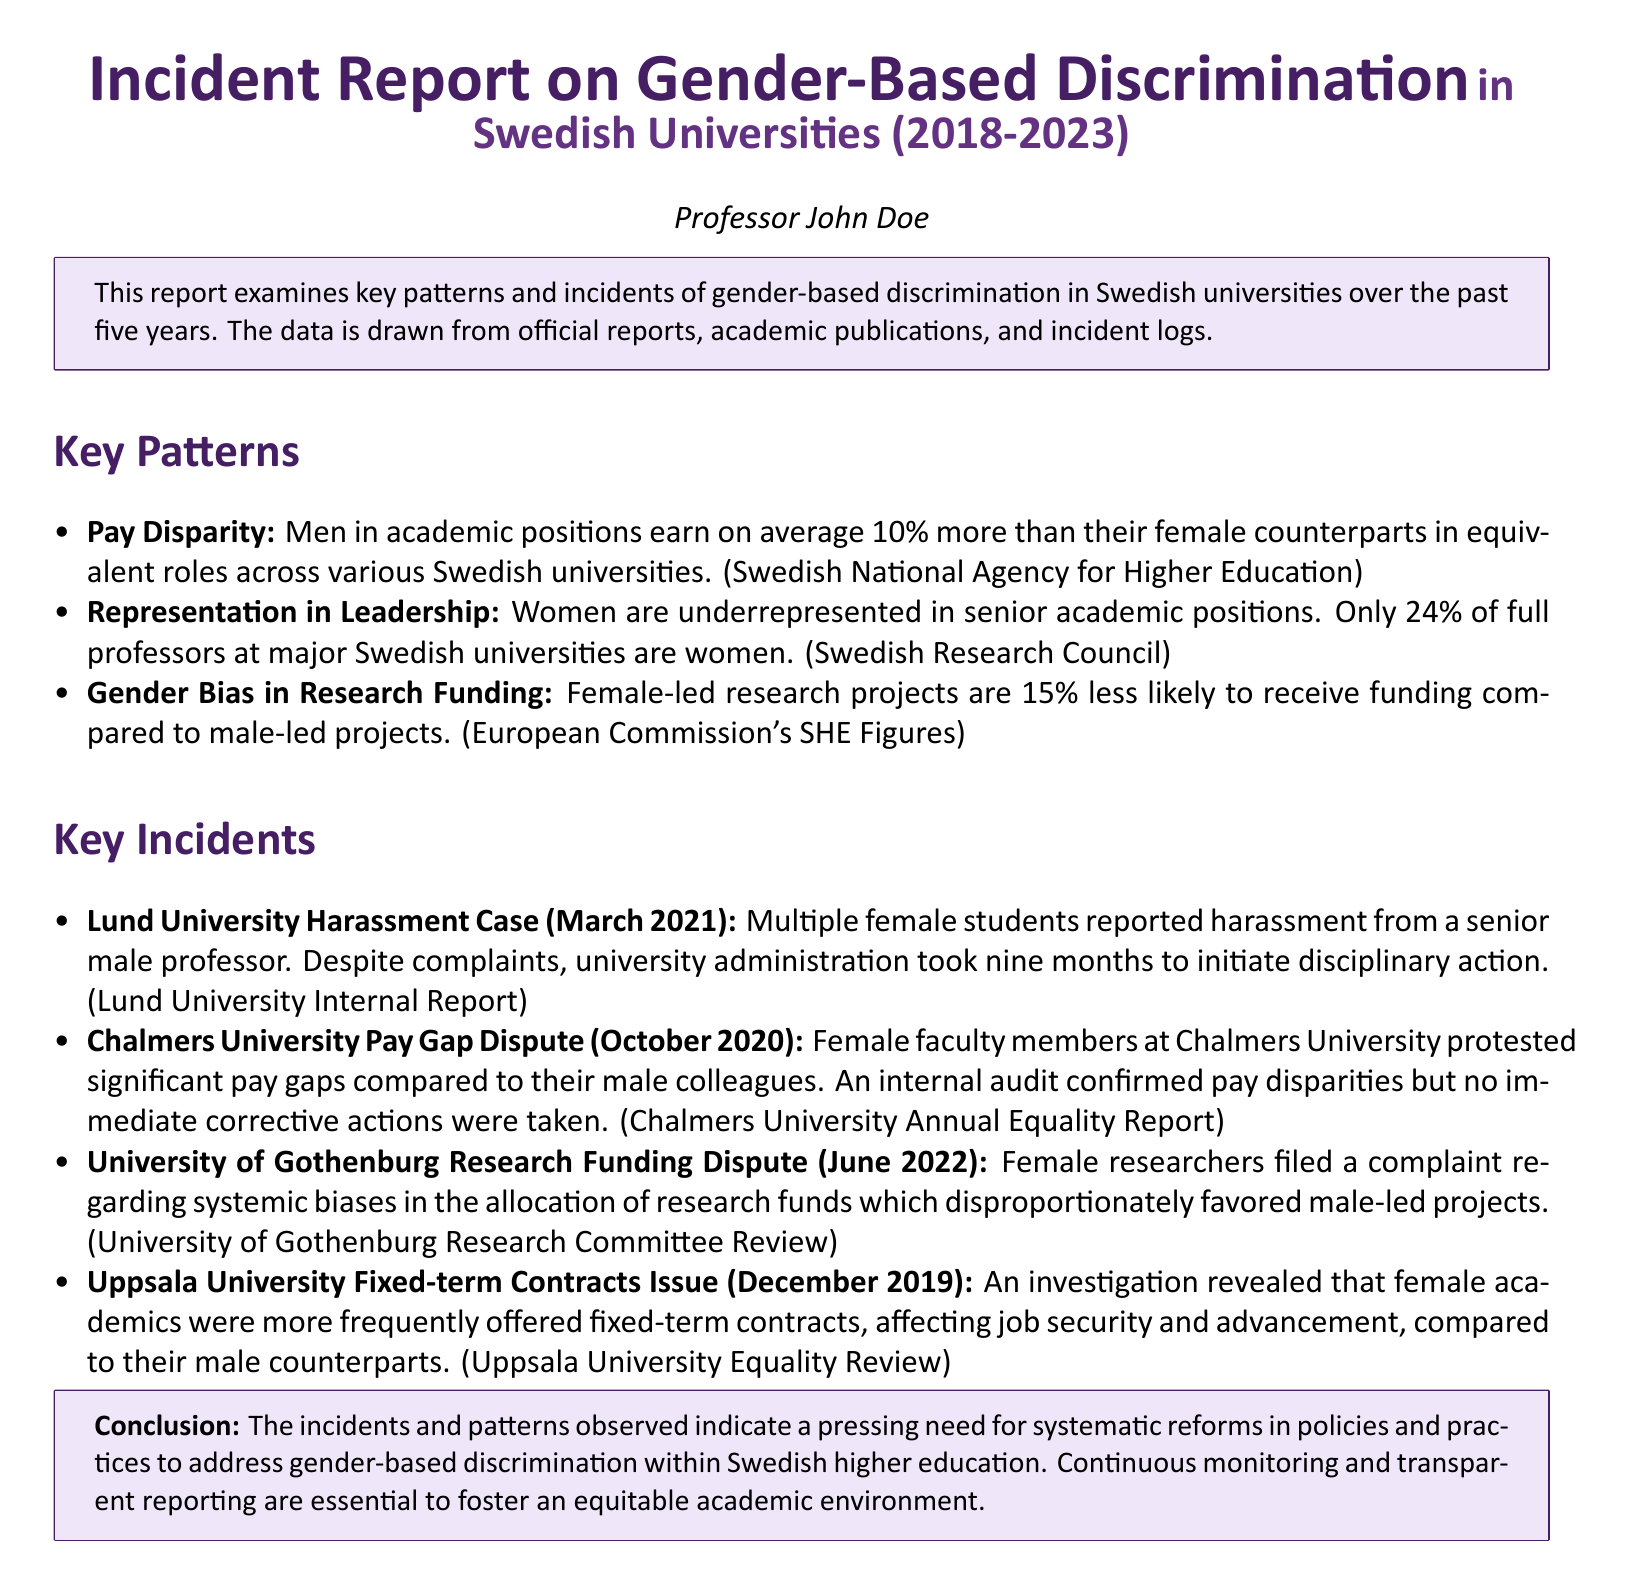What is the average pay disparity reported? The report states that men earn on average 10% more than their female counterparts in equivalent roles.
Answer: 10% What percentage of full professors are women? The document indicates that only 24% of full professors at major Swedish universities are women.
Answer: 24% Which university had a harassment case reported in 2021? The report specifies that the harassment case occurred at Lund University.
Answer: Lund University In what year did the pay gap dispute occur at Chalmers University? The document mentions that the pay gap dispute took place in October 2020.
Answer: October 2020 How much less likely are female-led research projects to receive funding? According to the report, female-led projects are 15% less likely to receive funding compared to male-led projects.
Answer: 15% What issue was revealed in the Uppsala University investigation? The investigation revealed that female academics were more frequently offered fixed-term contracts affecting their job security and advancement.
Answer: Fixed-term contracts Which incident involved a complaint about systemic biases in research funding? The document highlights the complaint involving female researchers at the University of Gothenburg.
Answer: University of Gothenburg What action was taken after the harassment complaints at Lund University? The university administration took nine months to initiate disciplinary action after the complaints.
Answer: Nine months 